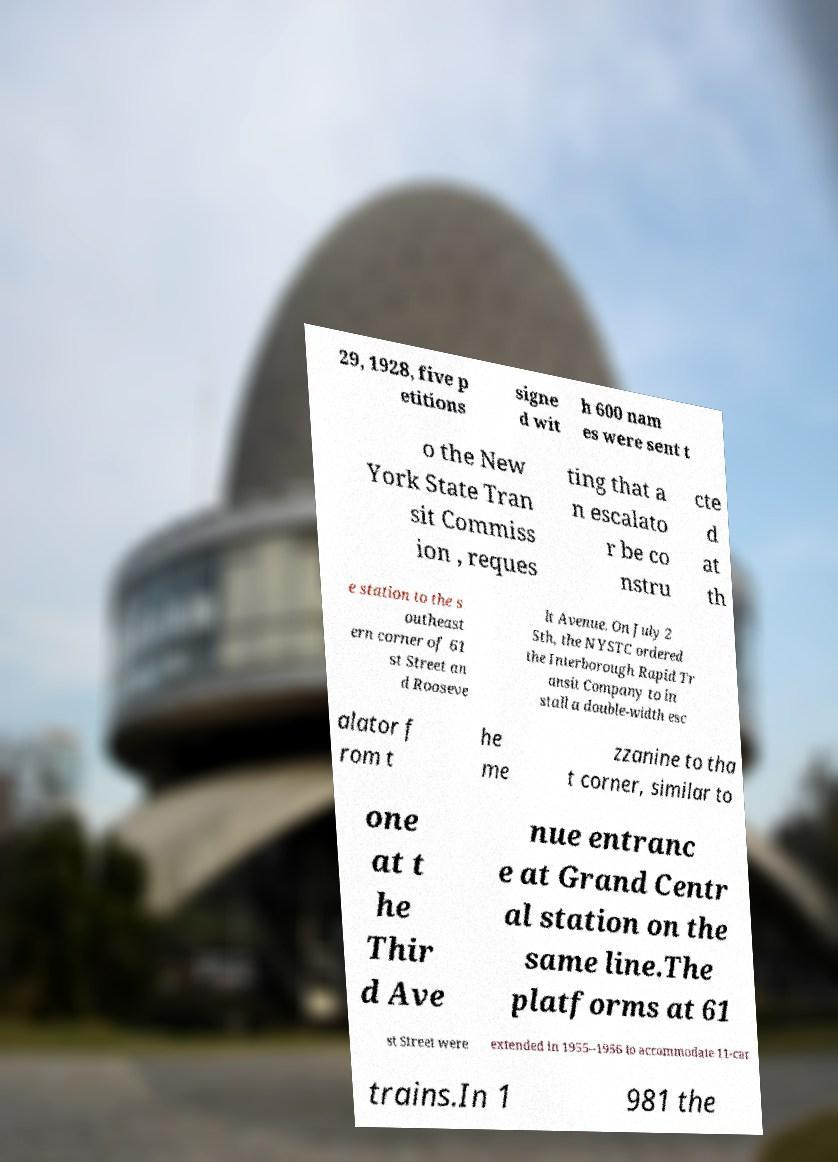For documentation purposes, I need the text within this image transcribed. Could you provide that? 29, 1928, five p etitions signe d wit h 600 nam es were sent t o the New York State Tran sit Commiss ion , reques ting that a n escalato r be co nstru cte d at th e station to the s outheast ern corner of 61 st Street an d Rooseve lt Avenue. On July 2 5th, the NYSTC ordered the Interborough Rapid Tr ansit Company to in stall a double-width esc alator f rom t he me zzanine to tha t corner, similar to one at t he Thir d Ave nue entranc e at Grand Centr al station on the same line.The platforms at 61 st Street were extended in 1955–1956 to accommodate 11-car trains.In 1 981 the 